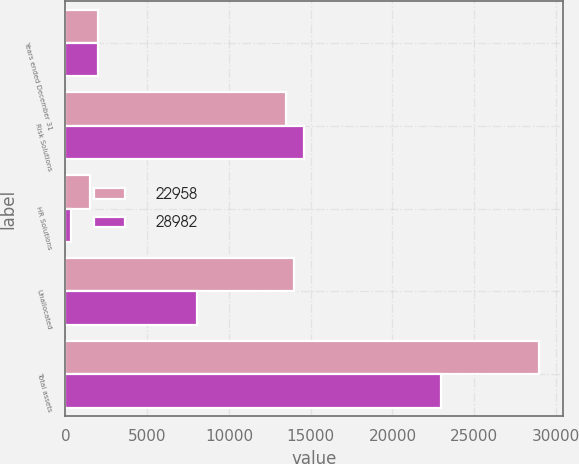Convert chart. <chart><loc_0><loc_0><loc_500><loc_500><stacked_bar_chart><ecel><fcel>Years ended December 31<fcel>Risk Solutions<fcel>HR Solutions<fcel>Unallocated<fcel>Total assets<nl><fcel>22958<fcel>2010<fcel>13475<fcel>1532<fcel>13975<fcel>28982<nl><fcel>28982<fcel>2009<fcel>14570<fcel>368<fcel>8020<fcel>22958<nl></chart> 